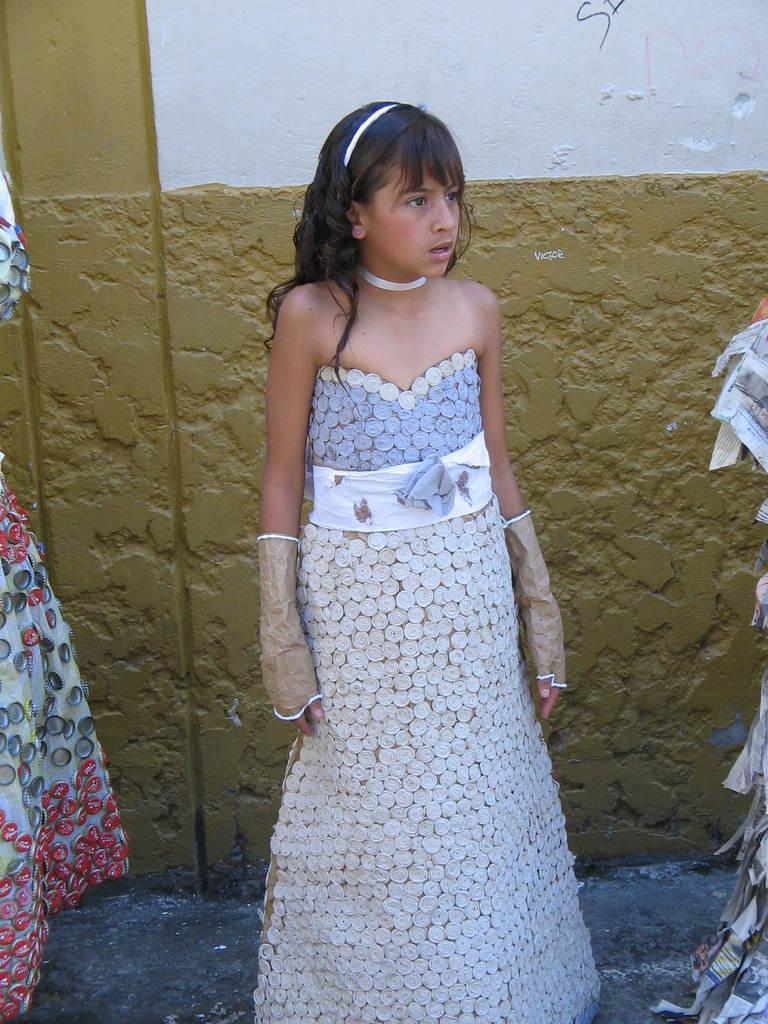What is the main subject of the image? There is a girl standing in the image. Where is the girl standing? The girl is standing on the ground. What can be seen on the right side of the image? There are papers on the right side of the image. What is located on the left side of the image? There is a dress on the left side of the image. What is visible in the background of the image? There is a wall in the background of the image. What type of sail is visible in the image? There is no sail present in the image. What kind of lace can be seen on the girl's dress in the image? The provided facts do not mention any lace on the girl's dress, so we cannot determine its presence or type. 